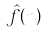<formula> <loc_0><loc_0><loc_500><loc_500>\hat { f } ( n )</formula> 